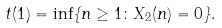<formula> <loc_0><loc_0><loc_500><loc_500>t ( 1 ) = \inf \{ n \geq 1 \colon X _ { 2 } ( n ) = 0 \} .</formula> 